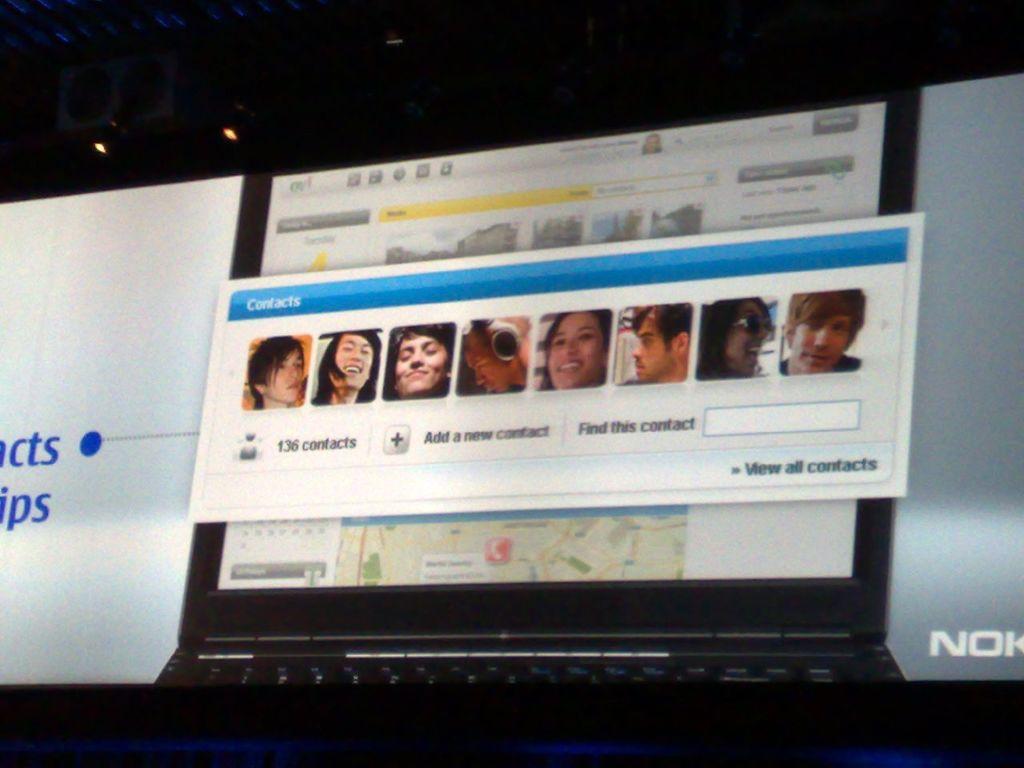What are those pictures of?
Provide a succinct answer. Contacts. What brand is in the bottom right?
Your response must be concise. Nokia. 